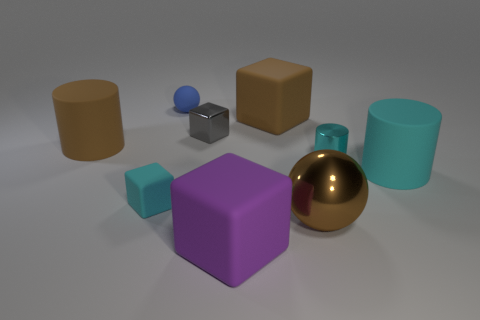Subtract all rubber cylinders. How many cylinders are left? 1 Subtract all brown spheres. How many spheres are left? 1 Subtract all cylinders. How many objects are left? 6 Subtract all green cubes. Subtract all yellow cylinders. How many cubes are left? 4 Subtract all yellow balls. How many cyan blocks are left? 1 Subtract all large purple matte cylinders. Subtract all large blocks. How many objects are left? 7 Add 7 big brown spheres. How many big brown spheres are left? 8 Add 3 cyan rubber blocks. How many cyan rubber blocks exist? 4 Subtract 1 gray blocks. How many objects are left? 8 Subtract 3 cylinders. How many cylinders are left? 0 